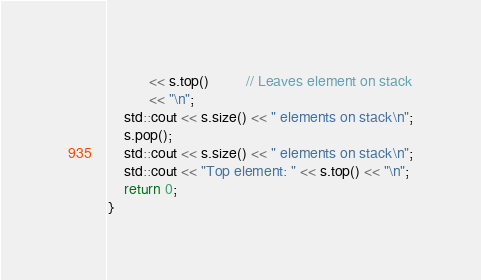Convert code to text. <code><loc_0><loc_0><loc_500><loc_500><_C++_>          << s.top()         // Leaves element on stack
          << "\n";
    std::cout << s.size() << " elements on stack\n";
    s.pop();
    std::cout << s.size() << " elements on stack\n";
    std::cout << "Top element: " << s.top() << "\n";
    return 0;
}

</code> 